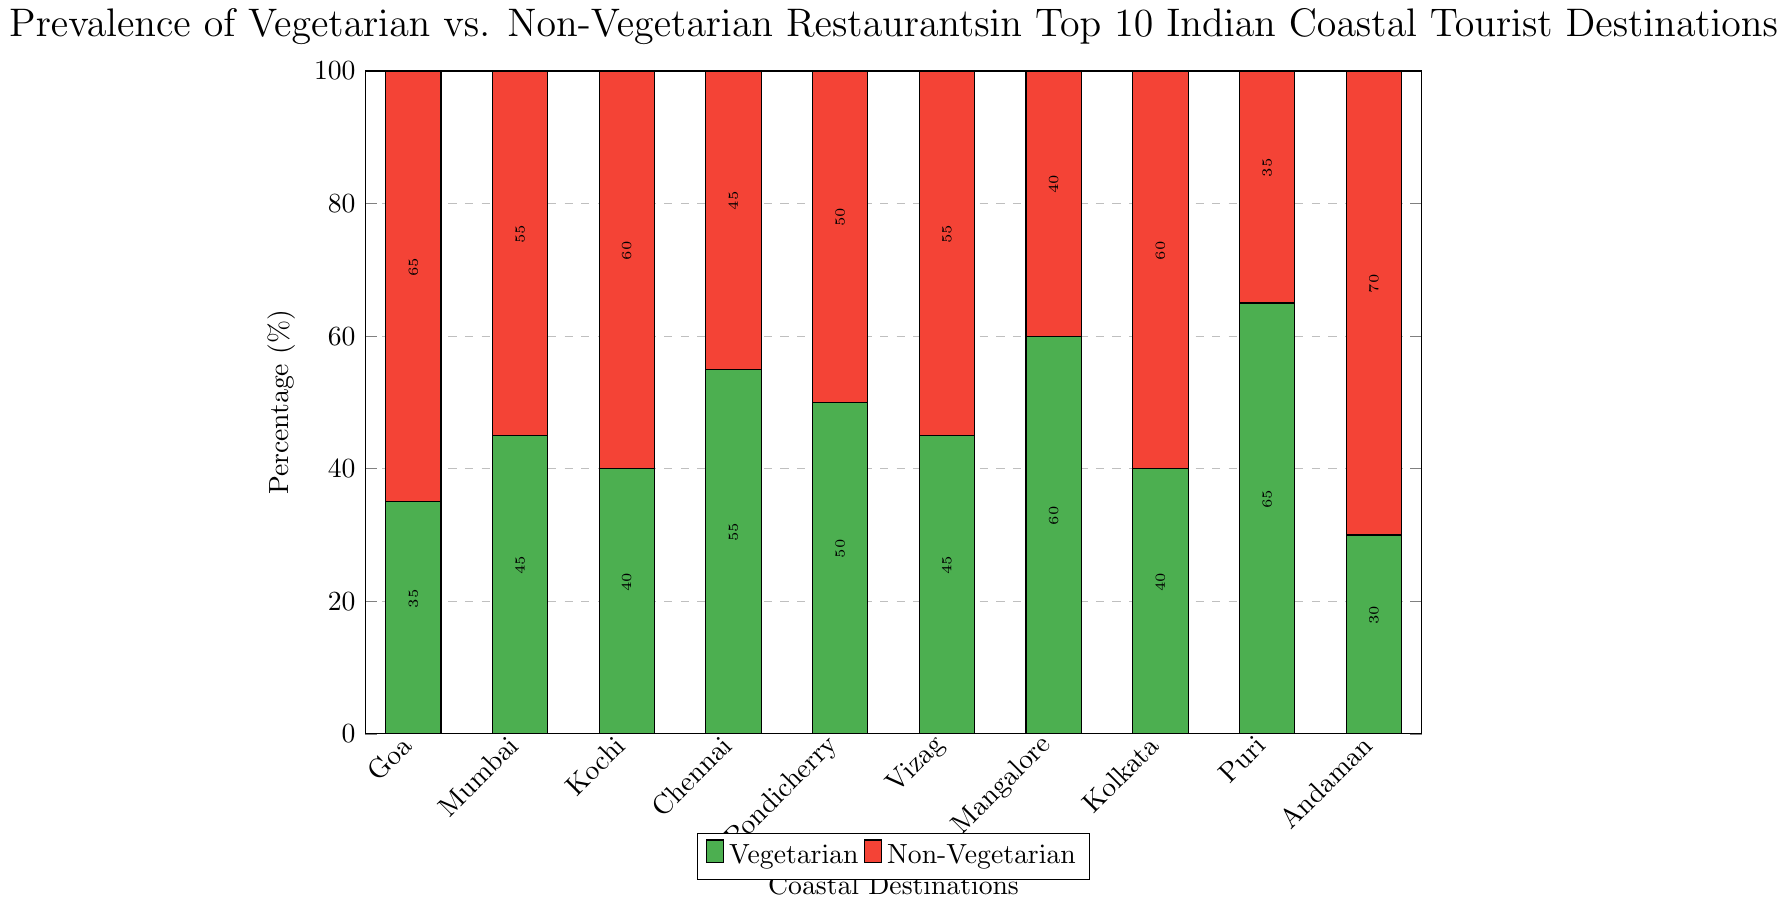What's the destination with the highest percentage of vegetarian restaurants? The bar chart shows the percentage of vegetarian restaurants for each destination. By comparing the heights of the green bars, Puri stands out with the highest percentage of 65%.
Answer: Puri How much higher is the percentage of non-vegetarian restaurants in Andaman Islands compared to vegetarian restaurants there? To find the difference, subtract the percentage of vegetarian restaurants (30%) from the percentage of non-vegetarian restaurants (70%) in Andaman Islands. 70% - 30% = 40%.
Answer: 40% Which destination has an equal percentage of vegetarian and non-vegetarian restaurants? The bar chart shows that Pondicherry has both vegetarian and non-vegetarian restaurants at 50%, indicating equal percentages.
Answer: Pondicherry Which coastal destination has the lowest percentage of vegetarian restaurants? By examining the green bars, Andaman Islands has the lowest percentage at 30%.
Answer: Andaman Islands What is the average percentage of vegetarian restaurants in Goa, Kochi, and Mumbai? To find the average, sum the percentages of vegetarian restaurants in these destinations and divide by 3. (35% + 40% + 45%) / 3 = 120% / 3 = 40%.
Answer: 40% Compare the percentage of vegetarian restaurants in Chennai and Mangalore. Which one is higher, and by how much? Chennai has 55% vegetarian restaurants, while Mangalore has 60%. Subtract Chennai's percentage from Mangalore's: 60% - 55% = 5%. Mangalore is higher.
Answer: Mangalore by 5% Which destination shows the closest balance between vegetarian and non-vegetarian restaurants? Pondicherry has an equal percentage of 50% for both types of restaurants, indicating the closest balance.
Answer: Pondicherry Calculate the combined percentage of vegetarian and non-vegetarian restaurants in Vizag. Adding the percentages of vegetarian (45%) and non-vegetarian (55%) restaurants in Vizag gives 45% + 55% = 100%.
Answer: 100% In which destination is the percentage difference between vegetarian and non-vegetarian restaurants the smallest? The smallest difference is found by comparing the balance between vegetarian and non-vegetarian bars. Pondicherry has a 0% difference because both types make up 50% each.
Answer: Pondicherry What is the total percentage of non-vegetarian restaurants in Kolkata, Chennai, and Mumbai? Adding the percentages of non-vegetarian restaurants in Kolkata (60%), Chennai (45%), and Mumbai (55%) yields 60% + 45% + 55% = 160%.
Answer: 160% 